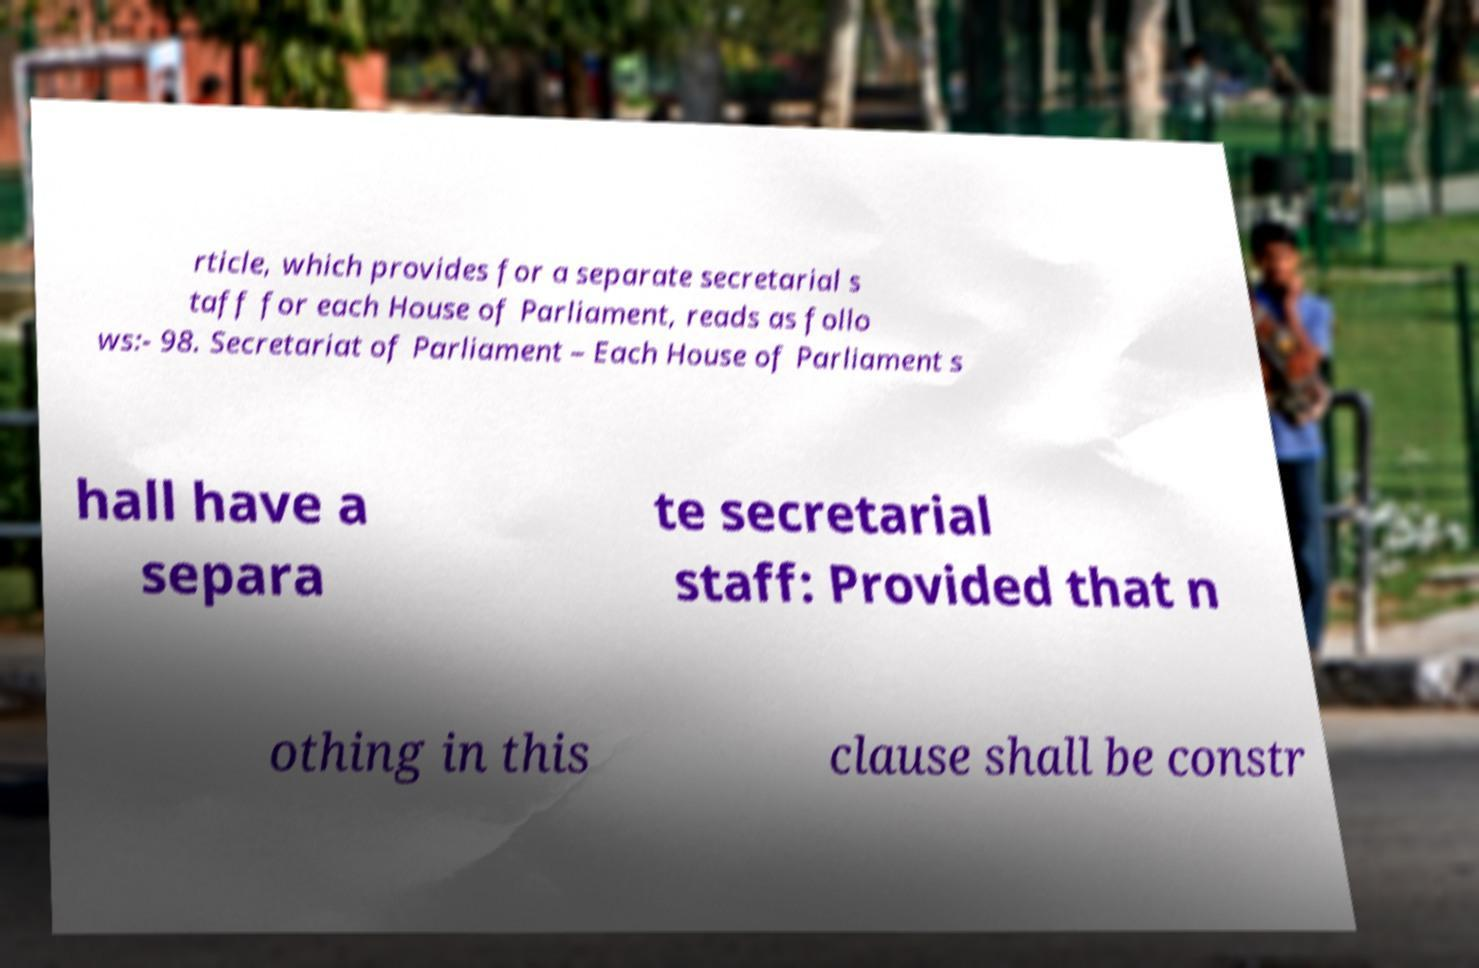There's text embedded in this image that I need extracted. Can you transcribe it verbatim? rticle, which provides for a separate secretarial s taff for each House of Parliament, reads as follo ws:- 98. Secretariat of Parliament – Each House of Parliament s hall have a separa te secretarial staff: Provided that n othing in this clause shall be constr 